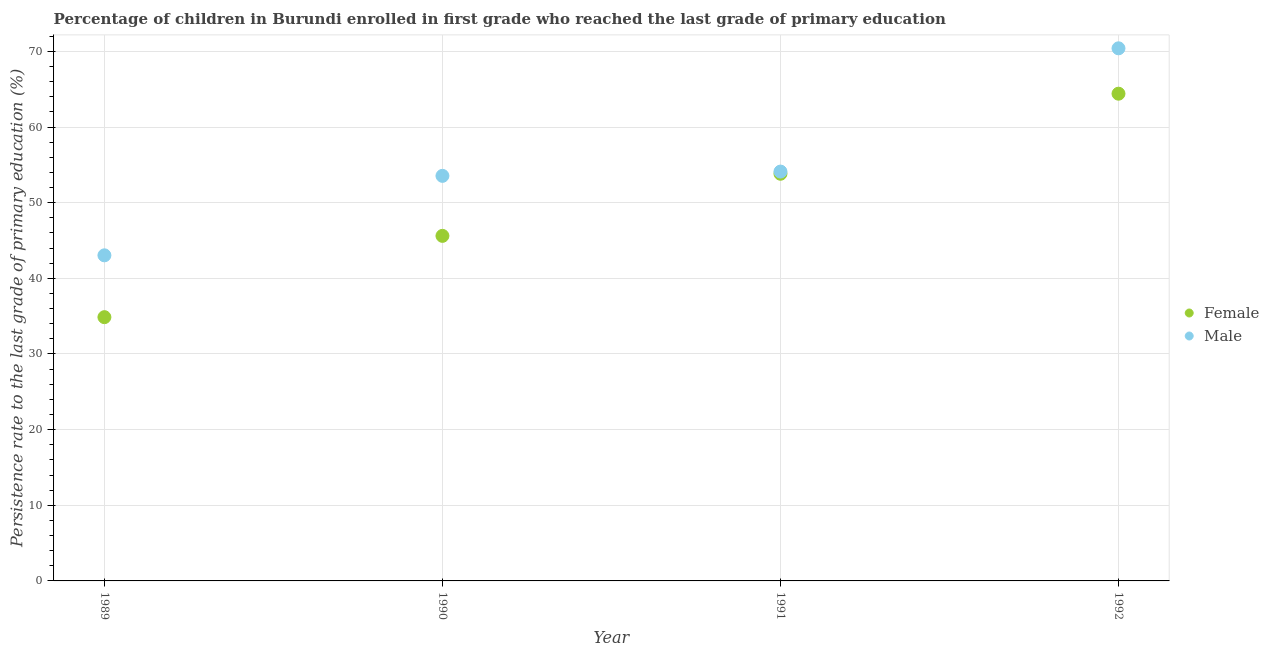Is the number of dotlines equal to the number of legend labels?
Make the answer very short. Yes. What is the persistence rate of male students in 1990?
Your answer should be compact. 53.55. Across all years, what is the maximum persistence rate of male students?
Make the answer very short. 70.41. Across all years, what is the minimum persistence rate of female students?
Provide a succinct answer. 34.87. In which year was the persistence rate of female students maximum?
Make the answer very short. 1992. What is the total persistence rate of female students in the graph?
Make the answer very short. 198.71. What is the difference between the persistence rate of female students in 1989 and that in 1990?
Offer a terse response. -10.75. What is the difference between the persistence rate of male students in 1992 and the persistence rate of female students in 1991?
Keep it short and to the point. 16.58. What is the average persistence rate of female students per year?
Your answer should be compact. 49.68. In the year 1992, what is the difference between the persistence rate of male students and persistence rate of female students?
Give a very brief answer. 6. What is the ratio of the persistence rate of male students in 1991 to that in 1992?
Give a very brief answer. 0.77. What is the difference between the highest and the second highest persistence rate of female students?
Ensure brevity in your answer.  10.58. What is the difference between the highest and the lowest persistence rate of female students?
Offer a terse response. 29.54. Is the sum of the persistence rate of female students in 1991 and 1992 greater than the maximum persistence rate of male students across all years?
Ensure brevity in your answer.  Yes. Does the persistence rate of female students monotonically increase over the years?
Your response must be concise. Yes. Is the persistence rate of male students strictly greater than the persistence rate of female students over the years?
Your answer should be very brief. Yes. Is the persistence rate of male students strictly less than the persistence rate of female students over the years?
Your answer should be compact. No. How many dotlines are there?
Offer a very short reply. 2. What is the difference between two consecutive major ticks on the Y-axis?
Your answer should be compact. 10. Are the values on the major ticks of Y-axis written in scientific E-notation?
Your answer should be compact. No. Where does the legend appear in the graph?
Ensure brevity in your answer.  Center right. How are the legend labels stacked?
Ensure brevity in your answer.  Vertical. What is the title of the graph?
Offer a very short reply. Percentage of children in Burundi enrolled in first grade who reached the last grade of primary education. Does "Registered firms" appear as one of the legend labels in the graph?
Provide a short and direct response. No. What is the label or title of the X-axis?
Your response must be concise. Year. What is the label or title of the Y-axis?
Offer a very short reply. Persistence rate to the last grade of primary education (%). What is the Persistence rate to the last grade of primary education (%) of Female in 1989?
Ensure brevity in your answer.  34.87. What is the Persistence rate to the last grade of primary education (%) in Male in 1989?
Offer a very short reply. 43.04. What is the Persistence rate to the last grade of primary education (%) in Female in 1990?
Keep it short and to the point. 45.61. What is the Persistence rate to the last grade of primary education (%) of Male in 1990?
Offer a very short reply. 53.55. What is the Persistence rate to the last grade of primary education (%) of Female in 1991?
Provide a succinct answer. 53.83. What is the Persistence rate to the last grade of primary education (%) in Male in 1991?
Ensure brevity in your answer.  54.11. What is the Persistence rate to the last grade of primary education (%) in Female in 1992?
Your answer should be compact. 64.41. What is the Persistence rate to the last grade of primary education (%) in Male in 1992?
Provide a short and direct response. 70.41. Across all years, what is the maximum Persistence rate to the last grade of primary education (%) in Female?
Keep it short and to the point. 64.41. Across all years, what is the maximum Persistence rate to the last grade of primary education (%) in Male?
Offer a terse response. 70.41. Across all years, what is the minimum Persistence rate to the last grade of primary education (%) in Female?
Your response must be concise. 34.87. Across all years, what is the minimum Persistence rate to the last grade of primary education (%) in Male?
Provide a short and direct response. 43.04. What is the total Persistence rate to the last grade of primary education (%) of Female in the graph?
Make the answer very short. 198.71. What is the total Persistence rate to the last grade of primary education (%) of Male in the graph?
Ensure brevity in your answer.  221.11. What is the difference between the Persistence rate to the last grade of primary education (%) of Female in 1989 and that in 1990?
Give a very brief answer. -10.75. What is the difference between the Persistence rate to the last grade of primary education (%) of Male in 1989 and that in 1990?
Make the answer very short. -10.5. What is the difference between the Persistence rate to the last grade of primary education (%) in Female in 1989 and that in 1991?
Keep it short and to the point. -18.96. What is the difference between the Persistence rate to the last grade of primary education (%) of Male in 1989 and that in 1991?
Your response must be concise. -11.07. What is the difference between the Persistence rate to the last grade of primary education (%) of Female in 1989 and that in 1992?
Ensure brevity in your answer.  -29.54. What is the difference between the Persistence rate to the last grade of primary education (%) in Male in 1989 and that in 1992?
Your answer should be very brief. -27.37. What is the difference between the Persistence rate to the last grade of primary education (%) of Female in 1990 and that in 1991?
Provide a short and direct response. -8.21. What is the difference between the Persistence rate to the last grade of primary education (%) of Male in 1990 and that in 1991?
Your answer should be very brief. -0.57. What is the difference between the Persistence rate to the last grade of primary education (%) in Female in 1990 and that in 1992?
Keep it short and to the point. -18.79. What is the difference between the Persistence rate to the last grade of primary education (%) in Male in 1990 and that in 1992?
Give a very brief answer. -16.86. What is the difference between the Persistence rate to the last grade of primary education (%) in Female in 1991 and that in 1992?
Keep it short and to the point. -10.58. What is the difference between the Persistence rate to the last grade of primary education (%) of Male in 1991 and that in 1992?
Your answer should be compact. -16.29. What is the difference between the Persistence rate to the last grade of primary education (%) of Female in 1989 and the Persistence rate to the last grade of primary education (%) of Male in 1990?
Offer a terse response. -18.68. What is the difference between the Persistence rate to the last grade of primary education (%) in Female in 1989 and the Persistence rate to the last grade of primary education (%) in Male in 1991?
Ensure brevity in your answer.  -19.25. What is the difference between the Persistence rate to the last grade of primary education (%) of Female in 1989 and the Persistence rate to the last grade of primary education (%) of Male in 1992?
Provide a succinct answer. -35.54. What is the difference between the Persistence rate to the last grade of primary education (%) of Female in 1990 and the Persistence rate to the last grade of primary education (%) of Male in 1991?
Your answer should be compact. -8.5. What is the difference between the Persistence rate to the last grade of primary education (%) in Female in 1990 and the Persistence rate to the last grade of primary education (%) in Male in 1992?
Make the answer very short. -24.79. What is the difference between the Persistence rate to the last grade of primary education (%) of Female in 1991 and the Persistence rate to the last grade of primary education (%) of Male in 1992?
Offer a very short reply. -16.58. What is the average Persistence rate to the last grade of primary education (%) of Female per year?
Your answer should be very brief. 49.68. What is the average Persistence rate to the last grade of primary education (%) in Male per year?
Your answer should be compact. 55.28. In the year 1989, what is the difference between the Persistence rate to the last grade of primary education (%) in Female and Persistence rate to the last grade of primary education (%) in Male?
Your answer should be compact. -8.17. In the year 1990, what is the difference between the Persistence rate to the last grade of primary education (%) of Female and Persistence rate to the last grade of primary education (%) of Male?
Provide a succinct answer. -7.93. In the year 1991, what is the difference between the Persistence rate to the last grade of primary education (%) in Female and Persistence rate to the last grade of primary education (%) in Male?
Your answer should be very brief. -0.29. In the year 1992, what is the difference between the Persistence rate to the last grade of primary education (%) in Female and Persistence rate to the last grade of primary education (%) in Male?
Provide a short and direct response. -6. What is the ratio of the Persistence rate to the last grade of primary education (%) of Female in 1989 to that in 1990?
Provide a succinct answer. 0.76. What is the ratio of the Persistence rate to the last grade of primary education (%) in Male in 1989 to that in 1990?
Provide a short and direct response. 0.8. What is the ratio of the Persistence rate to the last grade of primary education (%) of Female in 1989 to that in 1991?
Your answer should be compact. 0.65. What is the ratio of the Persistence rate to the last grade of primary education (%) of Male in 1989 to that in 1991?
Give a very brief answer. 0.8. What is the ratio of the Persistence rate to the last grade of primary education (%) in Female in 1989 to that in 1992?
Your answer should be very brief. 0.54. What is the ratio of the Persistence rate to the last grade of primary education (%) in Male in 1989 to that in 1992?
Provide a short and direct response. 0.61. What is the ratio of the Persistence rate to the last grade of primary education (%) of Female in 1990 to that in 1991?
Your answer should be compact. 0.85. What is the ratio of the Persistence rate to the last grade of primary education (%) of Male in 1990 to that in 1991?
Provide a short and direct response. 0.99. What is the ratio of the Persistence rate to the last grade of primary education (%) of Female in 1990 to that in 1992?
Your response must be concise. 0.71. What is the ratio of the Persistence rate to the last grade of primary education (%) of Male in 1990 to that in 1992?
Give a very brief answer. 0.76. What is the ratio of the Persistence rate to the last grade of primary education (%) of Female in 1991 to that in 1992?
Offer a very short reply. 0.84. What is the ratio of the Persistence rate to the last grade of primary education (%) in Male in 1991 to that in 1992?
Provide a succinct answer. 0.77. What is the difference between the highest and the second highest Persistence rate to the last grade of primary education (%) in Female?
Make the answer very short. 10.58. What is the difference between the highest and the second highest Persistence rate to the last grade of primary education (%) of Male?
Provide a short and direct response. 16.29. What is the difference between the highest and the lowest Persistence rate to the last grade of primary education (%) in Female?
Offer a very short reply. 29.54. What is the difference between the highest and the lowest Persistence rate to the last grade of primary education (%) in Male?
Give a very brief answer. 27.37. 